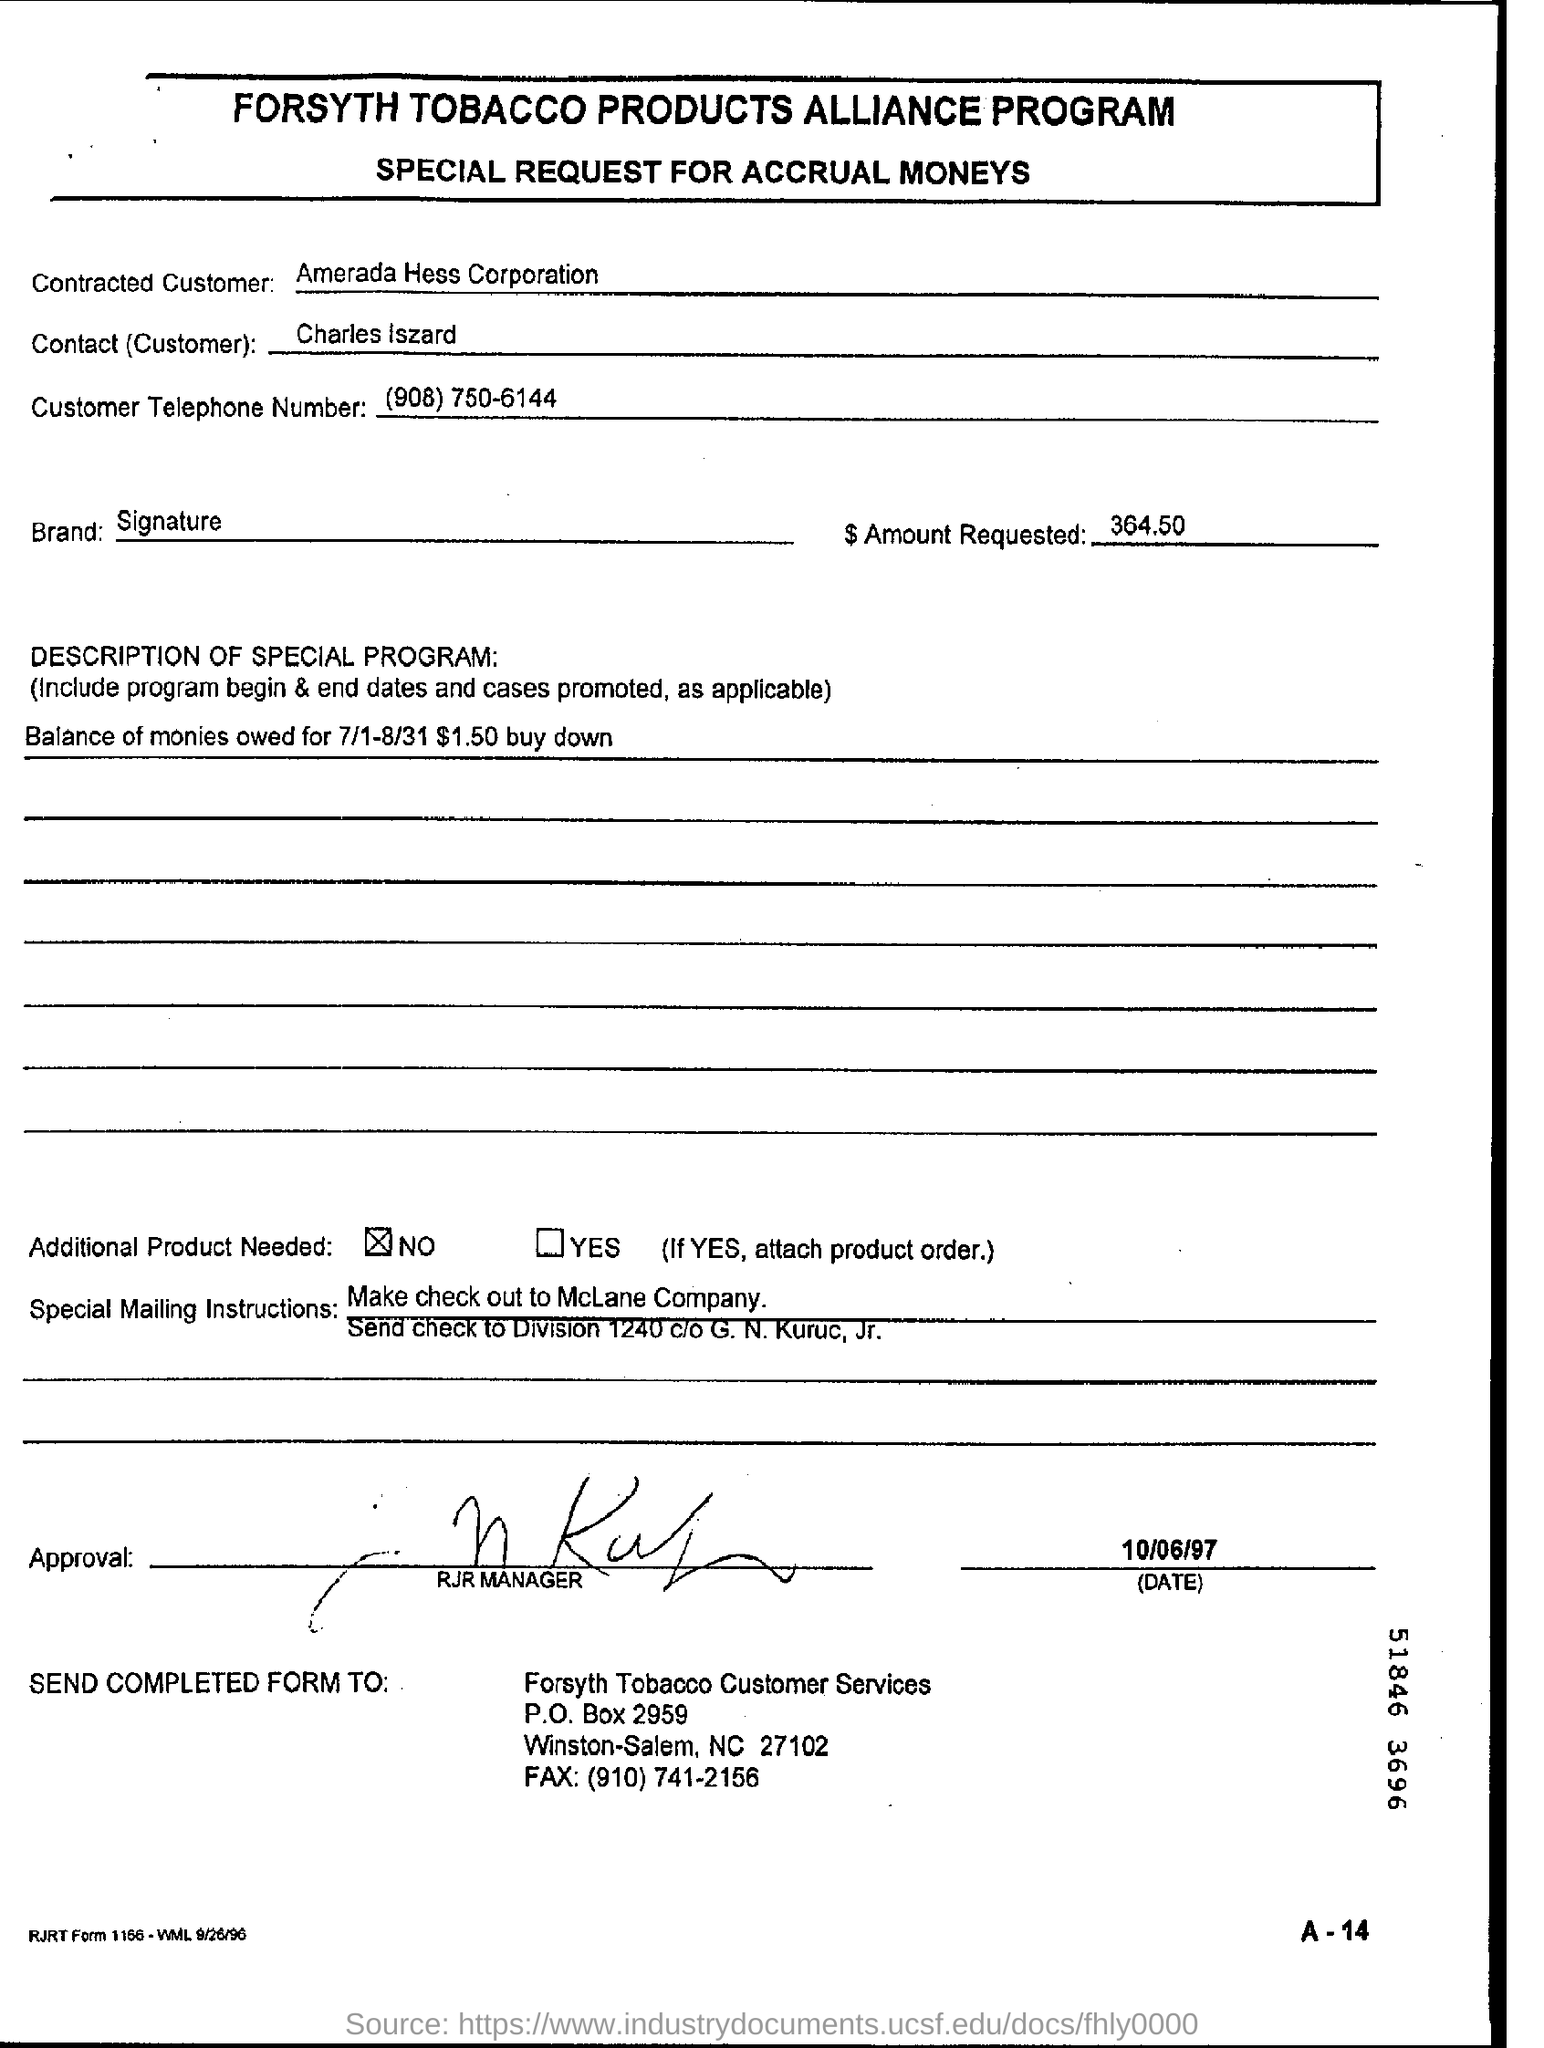Who is the Contracted Customer?
Provide a succinct answer. Amerada Hess Corporation. Who is the Contact(Customer)?
Keep it short and to the point. Charles Iszard. What is the Customer Telephone Number?
Provide a succinct answer. (908) 750-6144. What is the Brand?
Make the answer very short. Signature. 